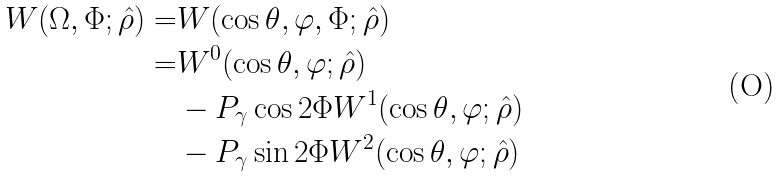Convert formula to latex. <formula><loc_0><loc_0><loc_500><loc_500>W ( \Omega , \Phi ; \hat { \rho } ) = & W ( \cos \theta , \varphi , \Phi ; \hat { \rho } ) \\ = & W ^ { 0 } ( \cos \theta , \varphi ; \hat { \rho } ) \\ & - P _ { \gamma } \cos 2 \Phi W ^ { 1 } ( \cos \theta , \varphi ; \hat { \rho } ) \\ & - P _ { \gamma } \sin 2 \Phi W ^ { 2 } ( \cos \theta , \varphi ; \hat { \rho } )</formula> 